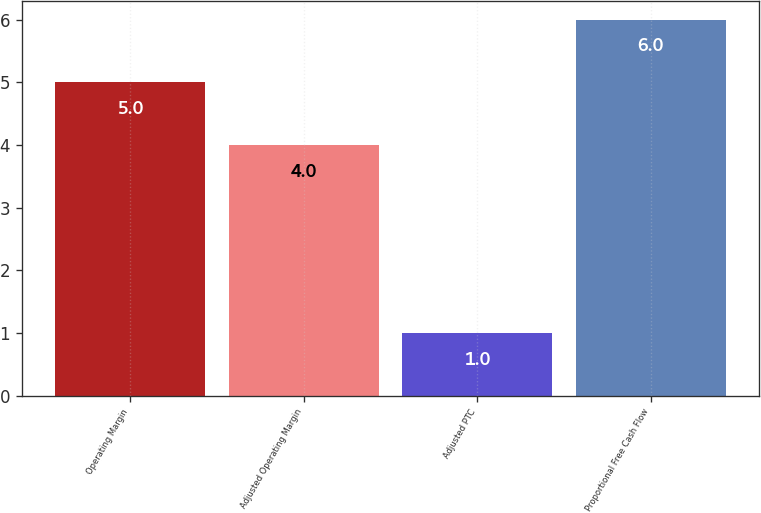<chart> <loc_0><loc_0><loc_500><loc_500><bar_chart><fcel>Operating Margin<fcel>Adjusted Operating Margin<fcel>Adjusted PTC<fcel>Proportional Free Cash Flow<nl><fcel>5<fcel>4<fcel>1<fcel>6<nl></chart> 